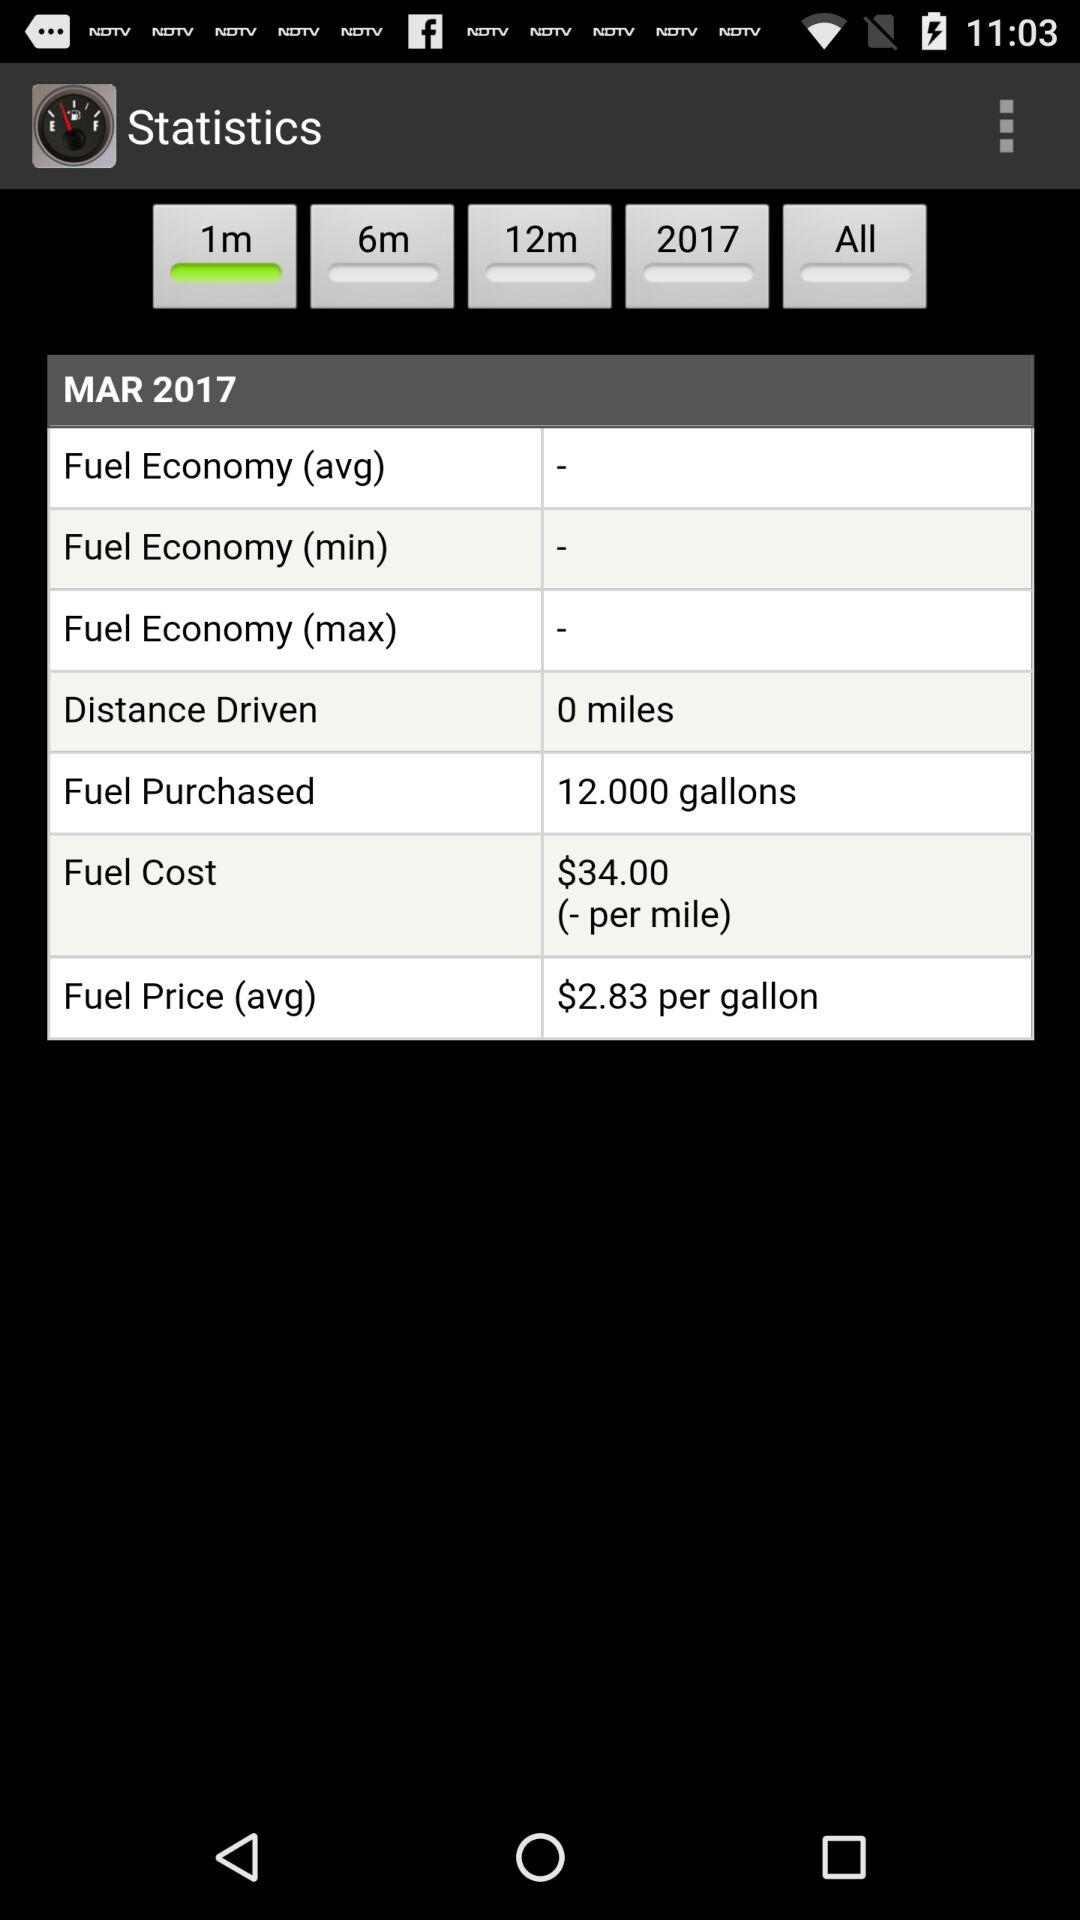What is the year mentioned in it? The year is 2017. 